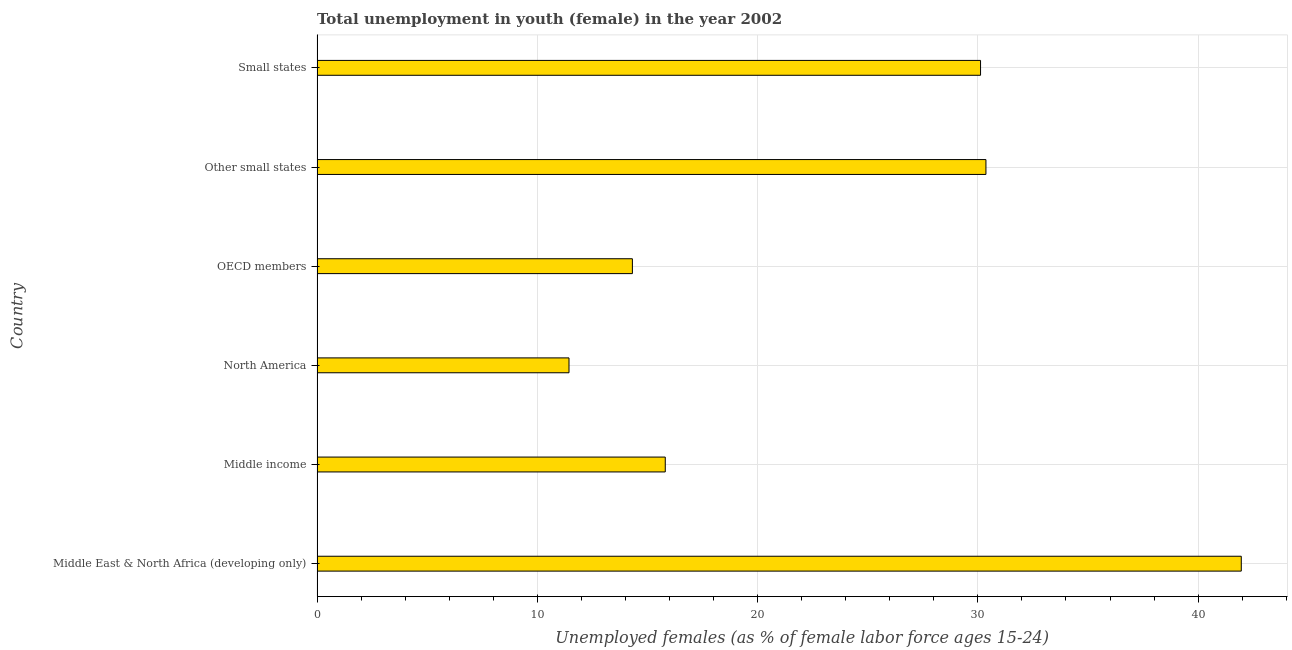Does the graph contain any zero values?
Your answer should be very brief. No. Does the graph contain grids?
Your answer should be very brief. Yes. What is the title of the graph?
Provide a short and direct response. Total unemployment in youth (female) in the year 2002. What is the label or title of the X-axis?
Provide a succinct answer. Unemployed females (as % of female labor force ages 15-24). What is the unemployed female youth population in Middle income?
Your response must be concise. 15.81. Across all countries, what is the maximum unemployed female youth population?
Make the answer very short. 41.96. Across all countries, what is the minimum unemployed female youth population?
Provide a short and direct response. 11.44. In which country was the unemployed female youth population maximum?
Your answer should be very brief. Middle East & North Africa (developing only). What is the sum of the unemployed female youth population?
Give a very brief answer. 144.01. What is the difference between the unemployed female youth population in Other small states and Small states?
Give a very brief answer. 0.24. What is the average unemployed female youth population per country?
Ensure brevity in your answer.  24. What is the median unemployed female youth population?
Provide a succinct answer. 22.96. In how many countries, is the unemployed female youth population greater than 40 %?
Provide a short and direct response. 1. What is the ratio of the unemployed female youth population in North America to that in OECD members?
Make the answer very short. 0.8. Is the unemployed female youth population in North America less than that in OECD members?
Provide a succinct answer. Yes. Is the difference between the unemployed female youth population in North America and OECD members greater than the difference between any two countries?
Keep it short and to the point. No. What is the difference between the highest and the second highest unemployed female youth population?
Offer a very short reply. 11.59. What is the difference between the highest and the lowest unemployed female youth population?
Keep it short and to the point. 30.52. Are all the bars in the graph horizontal?
Your answer should be compact. Yes. What is the Unemployed females (as % of female labor force ages 15-24) in Middle East & North Africa (developing only)?
Your answer should be compact. 41.96. What is the Unemployed females (as % of female labor force ages 15-24) of Middle income?
Your answer should be compact. 15.81. What is the Unemployed females (as % of female labor force ages 15-24) in North America?
Make the answer very short. 11.44. What is the Unemployed females (as % of female labor force ages 15-24) in OECD members?
Your response must be concise. 14.32. What is the Unemployed females (as % of female labor force ages 15-24) in Other small states?
Your answer should be compact. 30.37. What is the Unemployed females (as % of female labor force ages 15-24) in Small states?
Offer a very short reply. 30.12. What is the difference between the Unemployed females (as % of female labor force ages 15-24) in Middle East & North Africa (developing only) and Middle income?
Offer a terse response. 26.15. What is the difference between the Unemployed females (as % of female labor force ages 15-24) in Middle East & North Africa (developing only) and North America?
Provide a short and direct response. 30.52. What is the difference between the Unemployed females (as % of female labor force ages 15-24) in Middle East & North Africa (developing only) and OECD members?
Offer a very short reply. 27.64. What is the difference between the Unemployed females (as % of female labor force ages 15-24) in Middle East & North Africa (developing only) and Other small states?
Offer a terse response. 11.59. What is the difference between the Unemployed females (as % of female labor force ages 15-24) in Middle East & North Africa (developing only) and Small states?
Ensure brevity in your answer.  11.84. What is the difference between the Unemployed females (as % of female labor force ages 15-24) in Middle income and North America?
Offer a terse response. 4.37. What is the difference between the Unemployed females (as % of female labor force ages 15-24) in Middle income and OECD members?
Provide a short and direct response. 1.49. What is the difference between the Unemployed females (as % of female labor force ages 15-24) in Middle income and Other small states?
Provide a succinct answer. -14.56. What is the difference between the Unemployed females (as % of female labor force ages 15-24) in Middle income and Small states?
Provide a short and direct response. -14.31. What is the difference between the Unemployed females (as % of female labor force ages 15-24) in North America and OECD members?
Provide a short and direct response. -2.88. What is the difference between the Unemployed females (as % of female labor force ages 15-24) in North America and Other small states?
Offer a terse response. -18.93. What is the difference between the Unemployed females (as % of female labor force ages 15-24) in North America and Small states?
Offer a very short reply. -18.68. What is the difference between the Unemployed females (as % of female labor force ages 15-24) in OECD members and Other small states?
Ensure brevity in your answer.  -16.05. What is the difference between the Unemployed females (as % of female labor force ages 15-24) in OECD members and Small states?
Ensure brevity in your answer.  -15.81. What is the difference between the Unemployed females (as % of female labor force ages 15-24) in Other small states and Small states?
Your answer should be very brief. 0.24. What is the ratio of the Unemployed females (as % of female labor force ages 15-24) in Middle East & North Africa (developing only) to that in Middle income?
Keep it short and to the point. 2.65. What is the ratio of the Unemployed females (as % of female labor force ages 15-24) in Middle East & North Africa (developing only) to that in North America?
Provide a short and direct response. 3.67. What is the ratio of the Unemployed females (as % of female labor force ages 15-24) in Middle East & North Africa (developing only) to that in OECD members?
Offer a very short reply. 2.93. What is the ratio of the Unemployed females (as % of female labor force ages 15-24) in Middle East & North Africa (developing only) to that in Other small states?
Offer a very short reply. 1.38. What is the ratio of the Unemployed females (as % of female labor force ages 15-24) in Middle East & North Africa (developing only) to that in Small states?
Make the answer very short. 1.39. What is the ratio of the Unemployed females (as % of female labor force ages 15-24) in Middle income to that in North America?
Give a very brief answer. 1.38. What is the ratio of the Unemployed females (as % of female labor force ages 15-24) in Middle income to that in OECD members?
Provide a succinct answer. 1.1. What is the ratio of the Unemployed females (as % of female labor force ages 15-24) in Middle income to that in Other small states?
Your answer should be very brief. 0.52. What is the ratio of the Unemployed females (as % of female labor force ages 15-24) in Middle income to that in Small states?
Offer a very short reply. 0.53. What is the ratio of the Unemployed females (as % of female labor force ages 15-24) in North America to that in OECD members?
Provide a short and direct response. 0.8. What is the ratio of the Unemployed females (as % of female labor force ages 15-24) in North America to that in Other small states?
Your answer should be very brief. 0.38. What is the ratio of the Unemployed females (as % of female labor force ages 15-24) in North America to that in Small states?
Provide a succinct answer. 0.38. What is the ratio of the Unemployed females (as % of female labor force ages 15-24) in OECD members to that in Other small states?
Offer a very short reply. 0.47. What is the ratio of the Unemployed females (as % of female labor force ages 15-24) in OECD members to that in Small states?
Give a very brief answer. 0.47. 